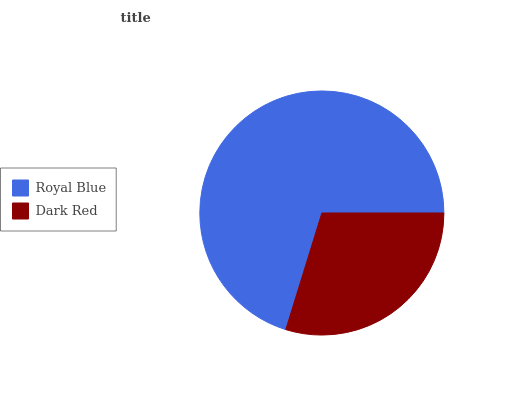Is Dark Red the minimum?
Answer yes or no. Yes. Is Royal Blue the maximum?
Answer yes or no. Yes. Is Dark Red the maximum?
Answer yes or no. No. Is Royal Blue greater than Dark Red?
Answer yes or no. Yes. Is Dark Red less than Royal Blue?
Answer yes or no. Yes. Is Dark Red greater than Royal Blue?
Answer yes or no. No. Is Royal Blue less than Dark Red?
Answer yes or no. No. Is Royal Blue the high median?
Answer yes or no. Yes. Is Dark Red the low median?
Answer yes or no. Yes. Is Dark Red the high median?
Answer yes or no. No. Is Royal Blue the low median?
Answer yes or no. No. 